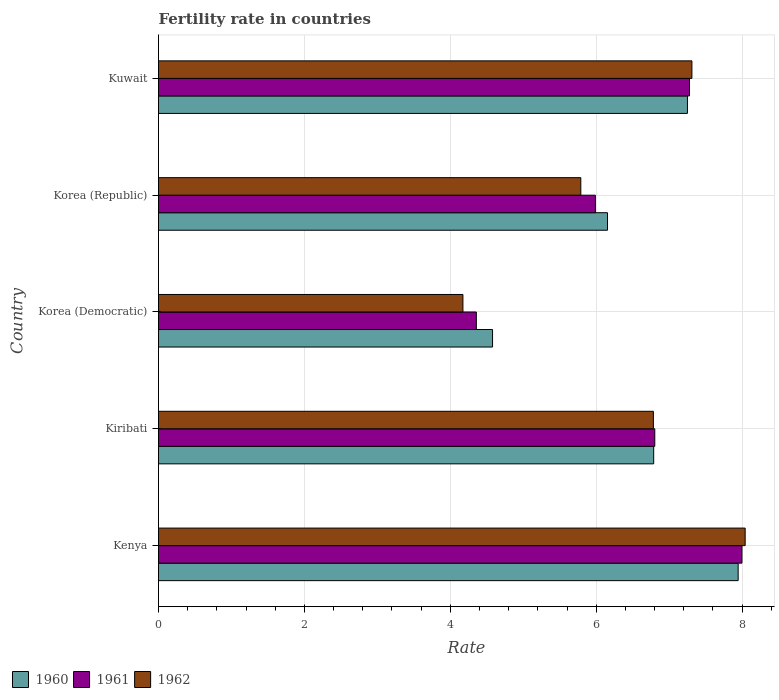How many bars are there on the 4th tick from the bottom?
Provide a succinct answer. 3. What is the label of the 1st group of bars from the top?
Make the answer very short. Kuwait. In how many cases, is the number of bars for a given country not equal to the number of legend labels?
Your answer should be compact. 0. What is the fertility rate in 1962 in Kenya?
Ensure brevity in your answer.  8.04. Across all countries, what is the maximum fertility rate in 1960?
Keep it short and to the point. 7.95. Across all countries, what is the minimum fertility rate in 1962?
Make the answer very short. 4.17. In which country was the fertility rate in 1961 maximum?
Ensure brevity in your answer.  Kenya. In which country was the fertility rate in 1960 minimum?
Ensure brevity in your answer.  Korea (Democratic). What is the total fertility rate in 1962 in the graph?
Provide a succinct answer. 32.1. What is the difference between the fertility rate in 1960 in Korea (Democratic) and that in Korea (Republic)?
Offer a terse response. -1.58. What is the difference between the fertility rate in 1962 in Kuwait and the fertility rate in 1961 in Korea (Republic)?
Make the answer very short. 1.32. What is the average fertility rate in 1962 per country?
Ensure brevity in your answer.  6.42. What is the difference between the fertility rate in 1960 and fertility rate in 1961 in Korea (Republic)?
Your answer should be very brief. 0.17. In how many countries, is the fertility rate in 1961 greater than 2 ?
Your answer should be very brief. 5. What is the ratio of the fertility rate in 1960 in Kenya to that in Kuwait?
Give a very brief answer. 1.1. What is the difference between the highest and the second highest fertility rate in 1961?
Your response must be concise. 0.72. What is the difference between the highest and the lowest fertility rate in 1962?
Provide a short and direct response. 3.87. In how many countries, is the fertility rate in 1961 greater than the average fertility rate in 1961 taken over all countries?
Your response must be concise. 3. What does the 1st bar from the top in Korea (Democratic) represents?
Offer a very short reply. 1962. What does the 2nd bar from the bottom in Kuwait represents?
Offer a very short reply. 1961. How many bars are there?
Provide a short and direct response. 15. How many countries are there in the graph?
Your answer should be very brief. 5. Are the values on the major ticks of X-axis written in scientific E-notation?
Give a very brief answer. No. Does the graph contain grids?
Provide a succinct answer. Yes. What is the title of the graph?
Offer a very short reply. Fertility rate in countries. Does "1974" appear as one of the legend labels in the graph?
Offer a very short reply. No. What is the label or title of the X-axis?
Offer a terse response. Rate. What is the Rate of 1960 in Kenya?
Ensure brevity in your answer.  7.95. What is the Rate of 1961 in Kenya?
Offer a terse response. 8. What is the Rate of 1962 in Kenya?
Offer a very short reply. 8.04. What is the Rate of 1960 in Kiribati?
Your answer should be compact. 6.79. What is the Rate in 1961 in Kiribati?
Offer a terse response. 6.8. What is the Rate of 1962 in Kiribati?
Your response must be concise. 6.78. What is the Rate in 1960 in Korea (Democratic)?
Make the answer very short. 4.58. What is the Rate of 1961 in Korea (Democratic)?
Make the answer very short. 4.36. What is the Rate of 1962 in Korea (Democratic)?
Your answer should be compact. 4.17. What is the Rate of 1960 in Korea (Republic)?
Your answer should be very brief. 6.16. What is the Rate of 1961 in Korea (Republic)?
Keep it short and to the point. 5.99. What is the Rate in 1962 in Korea (Republic)?
Your answer should be compact. 5.79. What is the Rate in 1960 in Kuwait?
Your answer should be very brief. 7.25. What is the Rate in 1961 in Kuwait?
Offer a very short reply. 7.28. What is the Rate of 1962 in Kuwait?
Your answer should be compact. 7.31. Across all countries, what is the maximum Rate of 1960?
Provide a short and direct response. 7.95. Across all countries, what is the maximum Rate of 1961?
Provide a succinct answer. 8. Across all countries, what is the maximum Rate in 1962?
Offer a terse response. 8.04. Across all countries, what is the minimum Rate of 1960?
Give a very brief answer. 4.58. Across all countries, what is the minimum Rate in 1961?
Your answer should be compact. 4.36. Across all countries, what is the minimum Rate in 1962?
Ensure brevity in your answer.  4.17. What is the total Rate in 1960 in the graph?
Provide a succinct answer. 32.72. What is the total Rate of 1961 in the graph?
Provide a short and direct response. 32.43. What is the total Rate in 1962 in the graph?
Your answer should be very brief. 32.1. What is the difference between the Rate in 1960 in Kenya and that in Kiribati?
Give a very brief answer. 1.16. What is the difference between the Rate in 1961 in Kenya and that in Kiribati?
Your response must be concise. 1.2. What is the difference between the Rate in 1962 in Kenya and that in Kiribati?
Provide a short and direct response. 1.26. What is the difference between the Rate of 1960 in Kenya and that in Korea (Democratic)?
Offer a terse response. 3.37. What is the difference between the Rate in 1961 in Kenya and that in Korea (Democratic)?
Your answer should be compact. 3.64. What is the difference between the Rate in 1962 in Kenya and that in Korea (Democratic)?
Offer a terse response. 3.87. What is the difference between the Rate in 1960 in Kenya and that in Korea (Republic)?
Keep it short and to the point. 1.79. What is the difference between the Rate in 1961 in Kenya and that in Korea (Republic)?
Ensure brevity in your answer.  2.01. What is the difference between the Rate of 1962 in Kenya and that in Korea (Republic)?
Provide a succinct answer. 2.25. What is the difference between the Rate of 1960 in Kenya and that in Kuwait?
Provide a succinct answer. 0.69. What is the difference between the Rate in 1961 in Kenya and that in Kuwait?
Your response must be concise. 0.72. What is the difference between the Rate in 1962 in Kenya and that in Kuwait?
Provide a succinct answer. 0.73. What is the difference between the Rate in 1960 in Kiribati and that in Korea (Democratic)?
Make the answer very short. 2.21. What is the difference between the Rate of 1961 in Kiribati and that in Korea (Democratic)?
Provide a short and direct response. 2.45. What is the difference between the Rate of 1962 in Kiribati and that in Korea (Democratic)?
Your answer should be compact. 2.61. What is the difference between the Rate in 1960 in Kiribati and that in Korea (Republic)?
Offer a terse response. 0.63. What is the difference between the Rate of 1961 in Kiribati and that in Korea (Republic)?
Your response must be concise. 0.81. What is the difference between the Rate of 1962 in Kiribati and that in Korea (Republic)?
Provide a succinct answer. 0.99. What is the difference between the Rate in 1960 in Kiribati and that in Kuwait?
Keep it short and to the point. -0.46. What is the difference between the Rate of 1961 in Kiribati and that in Kuwait?
Make the answer very short. -0.48. What is the difference between the Rate of 1962 in Kiribati and that in Kuwait?
Ensure brevity in your answer.  -0.53. What is the difference between the Rate of 1960 in Korea (Democratic) and that in Korea (Republic)?
Provide a short and direct response. -1.58. What is the difference between the Rate of 1961 in Korea (Democratic) and that in Korea (Republic)?
Ensure brevity in your answer.  -1.63. What is the difference between the Rate in 1962 in Korea (Democratic) and that in Korea (Republic)?
Give a very brief answer. -1.62. What is the difference between the Rate in 1960 in Korea (Democratic) and that in Kuwait?
Provide a succinct answer. -2.67. What is the difference between the Rate in 1961 in Korea (Democratic) and that in Kuwait?
Keep it short and to the point. -2.92. What is the difference between the Rate of 1962 in Korea (Democratic) and that in Kuwait?
Your answer should be very brief. -3.14. What is the difference between the Rate in 1960 in Korea (Republic) and that in Kuwait?
Your answer should be compact. -1.1. What is the difference between the Rate in 1961 in Korea (Republic) and that in Kuwait?
Ensure brevity in your answer.  -1.29. What is the difference between the Rate of 1962 in Korea (Republic) and that in Kuwait?
Offer a very short reply. -1.52. What is the difference between the Rate of 1960 in Kenya and the Rate of 1961 in Kiribati?
Provide a short and direct response. 1.14. What is the difference between the Rate of 1960 in Kenya and the Rate of 1962 in Kiribati?
Offer a terse response. 1.16. What is the difference between the Rate in 1961 in Kenya and the Rate in 1962 in Kiribati?
Give a very brief answer. 1.21. What is the difference between the Rate in 1960 in Kenya and the Rate in 1961 in Korea (Democratic)?
Give a very brief answer. 3.59. What is the difference between the Rate of 1960 in Kenya and the Rate of 1962 in Korea (Democratic)?
Give a very brief answer. 3.77. What is the difference between the Rate of 1961 in Kenya and the Rate of 1962 in Korea (Democratic)?
Give a very brief answer. 3.83. What is the difference between the Rate of 1960 in Kenya and the Rate of 1961 in Korea (Republic)?
Offer a terse response. 1.96. What is the difference between the Rate in 1960 in Kenya and the Rate in 1962 in Korea (Republic)?
Give a very brief answer. 2.16. What is the difference between the Rate in 1961 in Kenya and the Rate in 1962 in Korea (Republic)?
Provide a short and direct response. 2.21. What is the difference between the Rate in 1960 in Kenya and the Rate in 1961 in Kuwait?
Provide a short and direct response. 0.67. What is the difference between the Rate of 1960 in Kenya and the Rate of 1962 in Kuwait?
Make the answer very short. 0.63. What is the difference between the Rate of 1961 in Kenya and the Rate of 1962 in Kuwait?
Your response must be concise. 0.69. What is the difference between the Rate in 1960 in Kiribati and the Rate in 1961 in Korea (Democratic)?
Keep it short and to the point. 2.43. What is the difference between the Rate of 1960 in Kiribati and the Rate of 1962 in Korea (Democratic)?
Your answer should be very brief. 2.62. What is the difference between the Rate of 1961 in Kiribati and the Rate of 1962 in Korea (Democratic)?
Your answer should be very brief. 2.63. What is the difference between the Rate in 1960 in Kiribati and the Rate in 1961 in Korea (Republic)?
Offer a terse response. 0.8. What is the difference between the Rate of 1960 in Kiribati and the Rate of 1962 in Korea (Republic)?
Provide a succinct answer. 1. What is the difference between the Rate of 1961 in Kiribati and the Rate of 1962 in Korea (Republic)?
Give a very brief answer. 1.01. What is the difference between the Rate of 1960 in Kiribati and the Rate of 1961 in Kuwait?
Provide a succinct answer. -0.49. What is the difference between the Rate in 1960 in Kiribati and the Rate in 1962 in Kuwait?
Offer a very short reply. -0.52. What is the difference between the Rate in 1961 in Kiribati and the Rate in 1962 in Kuwait?
Provide a short and direct response. -0.51. What is the difference between the Rate of 1960 in Korea (Democratic) and the Rate of 1961 in Korea (Republic)?
Provide a short and direct response. -1.41. What is the difference between the Rate in 1960 in Korea (Democratic) and the Rate in 1962 in Korea (Republic)?
Offer a very short reply. -1.21. What is the difference between the Rate in 1961 in Korea (Democratic) and the Rate in 1962 in Korea (Republic)?
Your answer should be compact. -1.43. What is the difference between the Rate in 1960 in Korea (Democratic) and the Rate in 1961 in Kuwait?
Give a very brief answer. -2.7. What is the difference between the Rate of 1960 in Korea (Democratic) and the Rate of 1962 in Kuwait?
Offer a terse response. -2.73. What is the difference between the Rate in 1961 in Korea (Democratic) and the Rate in 1962 in Kuwait?
Provide a short and direct response. -2.96. What is the difference between the Rate in 1960 in Korea (Republic) and the Rate in 1961 in Kuwait?
Offer a very short reply. -1.12. What is the difference between the Rate in 1960 in Korea (Republic) and the Rate in 1962 in Kuwait?
Offer a terse response. -1.16. What is the difference between the Rate in 1961 in Korea (Republic) and the Rate in 1962 in Kuwait?
Make the answer very short. -1.32. What is the average Rate of 1960 per country?
Your response must be concise. 6.54. What is the average Rate in 1961 per country?
Your answer should be very brief. 6.49. What is the average Rate in 1962 per country?
Ensure brevity in your answer.  6.42. What is the difference between the Rate of 1960 and Rate of 1961 in Kenya?
Keep it short and to the point. -0.05. What is the difference between the Rate of 1960 and Rate of 1962 in Kenya?
Provide a succinct answer. -0.1. What is the difference between the Rate in 1961 and Rate in 1962 in Kenya?
Ensure brevity in your answer.  -0.04. What is the difference between the Rate of 1960 and Rate of 1961 in Kiribati?
Ensure brevity in your answer.  -0.01. What is the difference between the Rate in 1960 and Rate in 1962 in Kiribati?
Offer a terse response. 0. What is the difference between the Rate in 1961 and Rate in 1962 in Kiribati?
Give a very brief answer. 0.02. What is the difference between the Rate of 1960 and Rate of 1961 in Korea (Democratic)?
Offer a terse response. 0.22. What is the difference between the Rate of 1960 and Rate of 1962 in Korea (Democratic)?
Provide a succinct answer. 0.41. What is the difference between the Rate of 1961 and Rate of 1962 in Korea (Democratic)?
Your answer should be compact. 0.18. What is the difference between the Rate of 1960 and Rate of 1961 in Korea (Republic)?
Your answer should be very brief. 0.17. What is the difference between the Rate in 1960 and Rate in 1962 in Korea (Republic)?
Ensure brevity in your answer.  0.37. What is the difference between the Rate in 1960 and Rate in 1961 in Kuwait?
Keep it short and to the point. -0.03. What is the difference between the Rate in 1960 and Rate in 1962 in Kuwait?
Your response must be concise. -0.06. What is the difference between the Rate in 1961 and Rate in 1962 in Kuwait?
Offer a very short reply. -0.03. What is the ratio of the Rate of 1960 in Kenya to that in Kiribati?
Keep it short and to the point. 1.17. What is the ratio of the Rate of 1961 in Kenya to that in Kiribati?
Give a very brief answer. 1.18. What is the ratio of the Rate in 1962 in Kenya to that in Kiribati?
Give a very brief answer. 1.19. What is the ratio of the Rate of 1960 in Kenya to that in Korea (Democratic)?
Your answer should be compact. 1.74. What is the ratio of the Rate in 1961 in Kenya to that in Korea (Democratic)?
Ensure brevity in your answer.  1.84. What is the ratio of the Rate in 1962 in Kenya to that in Korea (Democratic)?
Your answer should be compact. 1.93. What is the ratio of the Rate of 1960 in Kenya to that in Korea (Republic)?
Ensure brevity in your answer.  1.29. What is the ratio of the Rate of 1961 in Kenya to that in Korea (Republic)?
Your answer should be compact. 1.34. What is the ratio of the Rate of 1962 in Kenya to that in Korea (Republic)?
Provide a short and direct response. 1.39. What is the ratio of the Rate of 1960 in Kenya to that in Kuwait?
Give a very brief answer. 1.1. What is the ratio of the Rate of 1961 in Kenya to that in Kuwait?
Your response must be concise. 1.1. What is the ratio of the Rate of 1962 in Kenya to that in Kuwait?
Your response must be concise. 1.1. What is the ratio of the Rate in 1960 in Kiribati to that in Korea (Democratic)?
Keep it short and to the point. 1.48. What is the ratio of the Rate of 1961 in Kiribati to that in Korea (Democratic)?
Keep it short and to the point. 1.56. What is the ratio of the Rate in 1962 in Kiribati to that in Korea (Democratic)?
Keep it short and to the point. 1.63. What is the ratio of the Rate of 1960 in Kiribati to that in Korea (Republic)?
Give a very brief answer. 1.1. What is the ratio of the Rate of 1961 in Kiribati to that in Korea (Republic)?
Ensure brevity in your answer.  1.14. What is the ratio of the Rate in 1962 in Kiribati to that in Korea (Republic)?
Give a very brief answer. 1.17. What is the ratio of the Rate in 1960 in Kiribati to that in Kuwait?
Offer a very short reply. 0.94. What is the ratio of the Rate of 1961 in Kiribati to that in Kuwait?
Your answer should be compact. 0.93. What is the ratio of the Rate in 1962 in Kiribati to that in Kuwait?
Give a very brief answer. 0.93. What is the ratio of the Rate of 1960 in Korea (Democratic) to that in Korea (Republic)?
Offer a very short reply. 0.74. What is the ratio of the Rate of 1961 in Korea (Democratic) to that in Korea (Republic)?
Provide a succinct answer. 0.73. What is the ratio of the Rate in 1962 in Korea (Democratic) to that in Korea (Republic)?
Provide a short and direct response. 0.72. What is the ratio of the Rate in 1960 in Korea (Democratic) to that in Kuwait?
Your response must be concise. 0.63. What is the ratio of the Rate of 1961 in Korea (Democratic) to that in Kuwait?
Keep it short and to the point. 0.6. What is the ratio of the Rate of 1962 in Korea (Democratic) to that in Kuwait?
Provide a short and direct response. 0.57. What is the ratio of the Rate in 1960 in Korea (Republic) to that in Kuwait?
Your answer should be compact. 0.85. What is the ratio of the Rate in 1961 in Korea (Republic) to that in Kuwait?
Make the answer very short. 0.82. What is the ratio of the Rate of 1962 in Korea (Republic) to that in Kuwait?
Provide a succinct answer. 0.79. What is the difference between the highest and the second highest Rate in 1960?
Your response must be concise. 0.69. What is the difference between the highest and the second highest Rate of 1961?
Make the answer very short. 0.72. What is the difference between the highest and the second highest Rate in 1962?
Ensure brevity in your answer.  0.73. What is the difference between the highest and the lowest Rate of 1960?
Give a very brief answer. 3.37. What is the difference between the highest and the lowest Rate in 1961?
Your answer should be compact. 3.64. What is the difference between the highest and the lowest Rate in 1962?
Keep it short and to the point. 3.87. 